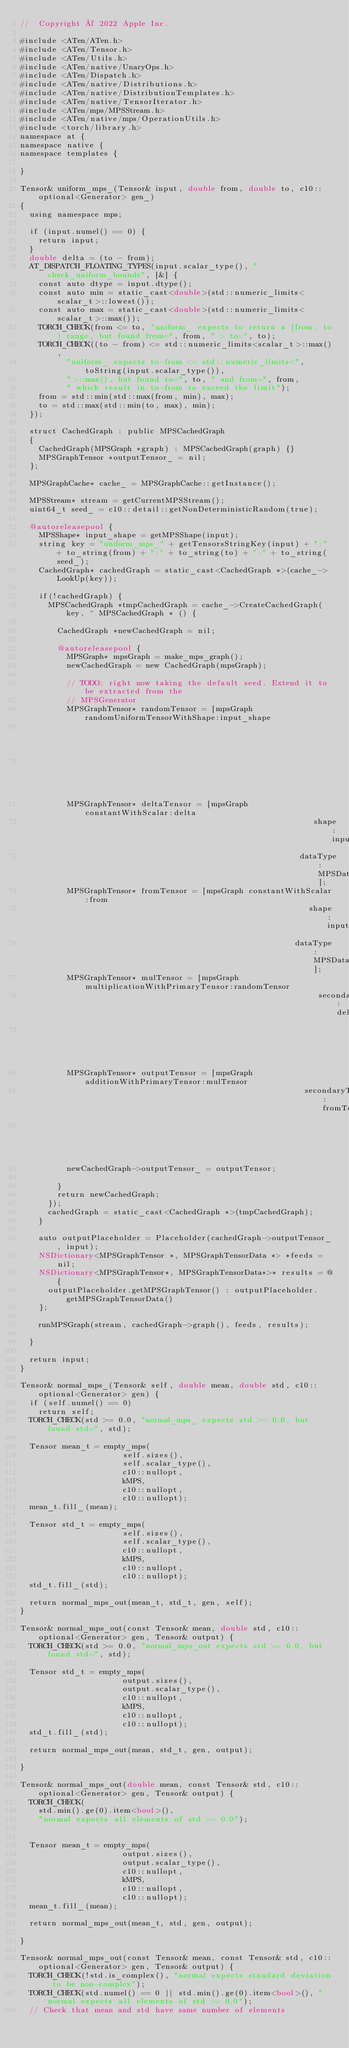<code> <loc_0><loc_0><loc_500><loc_500><_ObjectiveC_>//  Copyright © 2022 Apple Inc.

#include <ATen/ATen.h>
#include <ATen/Tensor.h>
#include <ATen/Utils.h>
#include <ATen/native/UnaryOps.h>
#include <ATen/Dispatch.h>
#include <ATen/native/Distributions.h>
#include <ATen/native/DistributionTemplates.h>
#include <ATen/native/TensorIterator.h>
#include <ATen/mps/MPSStream.h>
#include <ATen/native/mps/OperationUtils.h>
#include <torch/library.h>
namespace at {
namespace native {
namespace templates {

}

Tensor& uniform_mps_(Tensor& input, double from, double to, c10::optional<Generator> gen_)
{
  using namespace mps;

  if (input.numel() == 0) {
    return input;
  }
  double delta = (to - from);
  AT_DISPATCH_FLOATING_TYPES(input.scalar_type(), "check_uniform_bounds", [&] {
    const auto dtype = input.dtype();
    const auto min = static_cast<double>(std::numeric_limits<scalar_t>::lowest());
    const auto max = static_cast<double>(std::numeric_limits<scalar_t>::max());
    TORCH_CHECK(from <= to, "uniform_ expects to return a [from, to) range, but found from=", from, " > to=", to);
    TORCH_CHECK((to - from) <= std::numeric_limits<scalar_t>::max(),
          "uniform_ expects to-from <= std::numeric_limits<", toString(input.scalar_type()),
          ">::max(), but found to=", to, " and from=", from,
          " which result in to-from to exceed the limit");
    from = std::min(std::max(from, min), max);
    to = std::max(std::min(to, max), min);
  });

  struct CachedGraph : public MPSCachedGraph
  {
    CachedGraph(MPSGraph *graph) : MPSCachedGraph(graph) {}
    MPSGraphTensor *outputTensor_ = nil;
  };

  MPSGraphCache* cache_ = MPSGraphCache::getInstance();

  MPSStream* stream = getCurrentMPSStream();
  uint64_t seed_ = c10::detail::getNonDeterministicRandom(true);

  @autoreleasepool {
    MPSShape* input_shape = getMPSShape(input);
    string key = "uniform_mps_" + getTensorsStringKey(input) + ":" + to_string(from) + ":" + to_string(to) + ":" + to_string(seed_);
    CachedGraph* cachedGraph = static_cast<CachedGraph *>(cache_->LookUp(key));

    if(!cachedGraph) {
      MPSCachedGraph *tmpCachedGraph = cache_->CreateCachedGraph(key, ^ MPSCachedGraph * () {

        CachedGraph *newCachedGraph = nil;

        @autoreleasepool {
          MPSGraph* mpsGraph = make_mps_graph();
          newCachedGraph = new CachedGraph(mpsGraph);

          // TODO: right now taking the default seed. Extend it to be extracted from the
          // MPSGenerator
          MPSGraphTensor* randomTensor = [mpsGraph randomUniformTensorWithShape:input_shape
                                                                           seed:seed_
                                                                           name:nil];
          MPSGraphTensor* deltaTensor = [mpsGraph constantWithScalar:delta
                                                               shape:input_shape
                                                            dataType:MPSDataTypeFloat32];
          MPSGraphTensor* fromTensor = [mpsGraph constantWithScalar:from
                                                              shape:input_shape
                                                           dataType:MPSDataTypeFloat32];
          MPSGraphTensor* mulTensor = [mpsGraph multiplicationWithPrimaryTensor:randomTensor
                                                                secondaryTensor:deltaTensor
                                                                           name:nil];
          MPSGraphTensor* outputTensor = [mpsGraph additionWithPrimaryTensor:mulTensor
                                                             secondaryTensor:fromTensor
                                                                        name:nil];
          newCachedGraph->outputTensor_ = outputTensor;

        }
        return newCachedGraph;
      });
      cachedGraph = static_cast<CachedGraph *>(tmpCachedGraph);
    }

    auto outputPlaceholder = Placeholder(cachedGraph->outputTensor_, input);
    NSDictionary<MPSGraphTensor *, MPSGraphTensorData *> *feeds = nil;
    NSDictionary<MPSGraphTensor*, MPSGraphTensorData*>* results = @{
      outputPlaceholder.getMPSGraphTensor() : outputPlaceholder.getMPSGraphTensorData()
    };

    runMPSGraph(stream, cachedGraph->graph(), feeds, results);

  }

  return input;
}

Tensor& normal_mps_(Tensor& self, double mean, double std, c10::optional<Generator> gen) {
  if (self.numel() == 0)
    return self;
  TORCH_CHECK(std >= 0.0, "normal_mps_ expects std >= 0.0, but found std=", std);

  Tensor mean_t = empty_mps(
                      self.sizes(),
                      self.scalar_type(),
                      c10::nullopt,
                      kMPS,
                      c10::nullopt,
                      c10::nullopt);
  mean_t.fill_(mean);

  Tensor std_t = empty_mps(
                      self.sizes(),
                      self.scalar_type(),
                      c10::nullopt,
                      kMPS,
                      c10::nullopt,
                      c10::nullopt);
  std_t.fill_(std);

  return normal_mps_out(mean_t, std_t, gen, self);
}

Tensor& normal_mps_out(const Tensor& mean, double std, c10::optional<Generator> gen, Tensor& output) {
  TORCH_CHECK(std >= 0.0, "normal_mps_out expects std >= 0.0, but found std=", std);

  Tensor std_t = empty_mps(
                      output.sizes(),
                      output.scalar_type(),
                      c10::nullopt,
                      kMPS,
                      c10::nullopt,
                      c10::nullopt);
  std_t.fill_(std);

  return normal_mps_out(mean, std_t, gen, output);

}

Tensor& normal_mps_out(double mean, const Tensor& std, c10::optional<Generator> gen, Tensor& output) {
  TORCH_CHECK(
    std.min().ge(0).item<bool>(),
    "normal expects all elements of std >= 0.0");


  Tensor mean_t = empty_mps(
                      output.sizes(),
                      output.scalar_type(),
                      c10::nullopt,
                      kMPS,
                      c10::nullopt,
                      c10::nullopt);
  mean_t.fill_(mean);

  return normal_mps_out(mean_t, std, gen, output);

}

Tensor& normal_mps_out(const Tensor& mean, const Tensor& std, c10::optional<Generator> gen, Tensor& output) {
  TORCH_CHECK(!std.is_complex(), "normal expects standard deviation to be non-complex");
  TORCH_CHECK(std.numel() == 0 || std.min().ge(0).item<bool>(), "normal expects all elements of std >= 0.0");
  // Check that mean and std have same number of elements</code> 